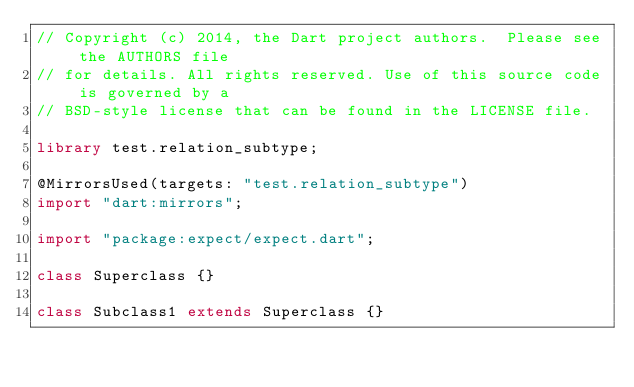Convert code to text. <code><loc_0><loc_0><loc_500><loc_500><_Dart_>// Copyright (c) 2014, the Dart project authors.  Please see the AUTHORS file
// for details. All rights reserved. Use of this source code is governed by a
// BSD-style license that can be found in the LICENSE file.

library test.relation_subtype;

@MirrorsUsed(targets: "test.relation_subtype")
import "dart:mirrors";

import "package:expect/expect.dart";

class Superclass {}

class Subclass1 extends Superclass {}
</code> 